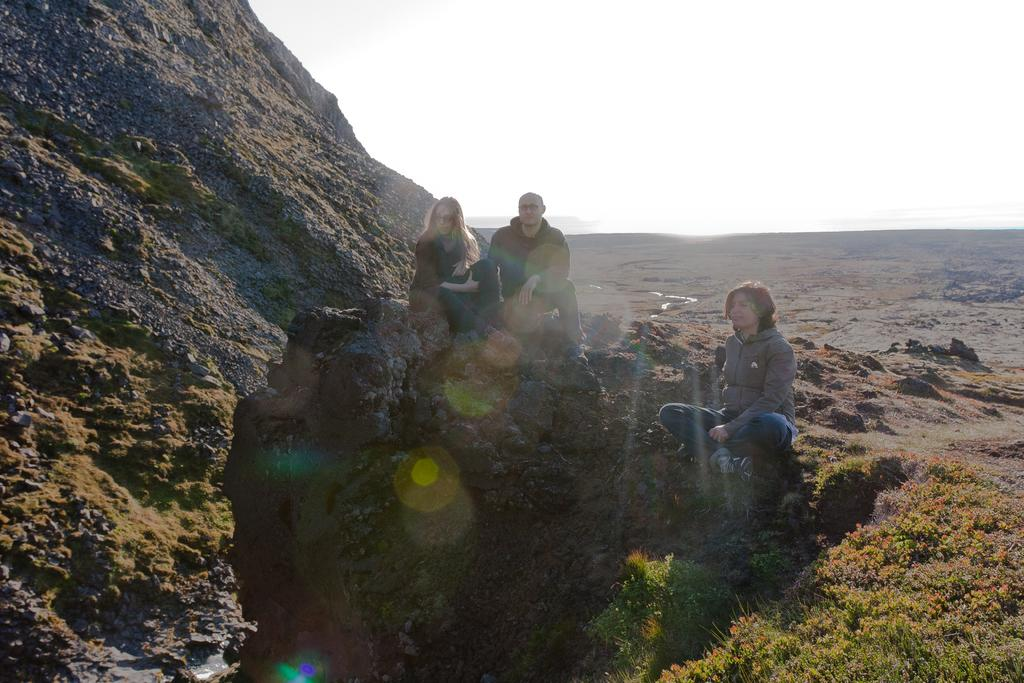Where was the image taken? The image was clicked outside. What are the three persons in the image doing? The three persons are sitting on rocks. What type of natural environment is visible at the bottom of the image? There are plants and grass at the bottom of the image. What is visible at the top of the image? There is sky visible at the top of the image. What type of roof can be seen in the image? There is no roof present in the image; it was taken outside. Is there a stranger walking towards the group in the image? There is no stranger visible in the image; it only shows three persons sitting on rocks. 